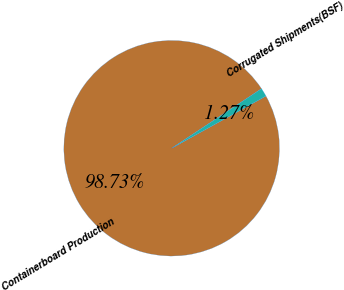<chart> <loc_0><loc_0><loc_500><loc_500><pie_chart><fcel>Containerboard Production<fcel>Corrugated Shipments(BSF)<nl><fcel>98.73%<fcel>1.27%<nl></chart> 